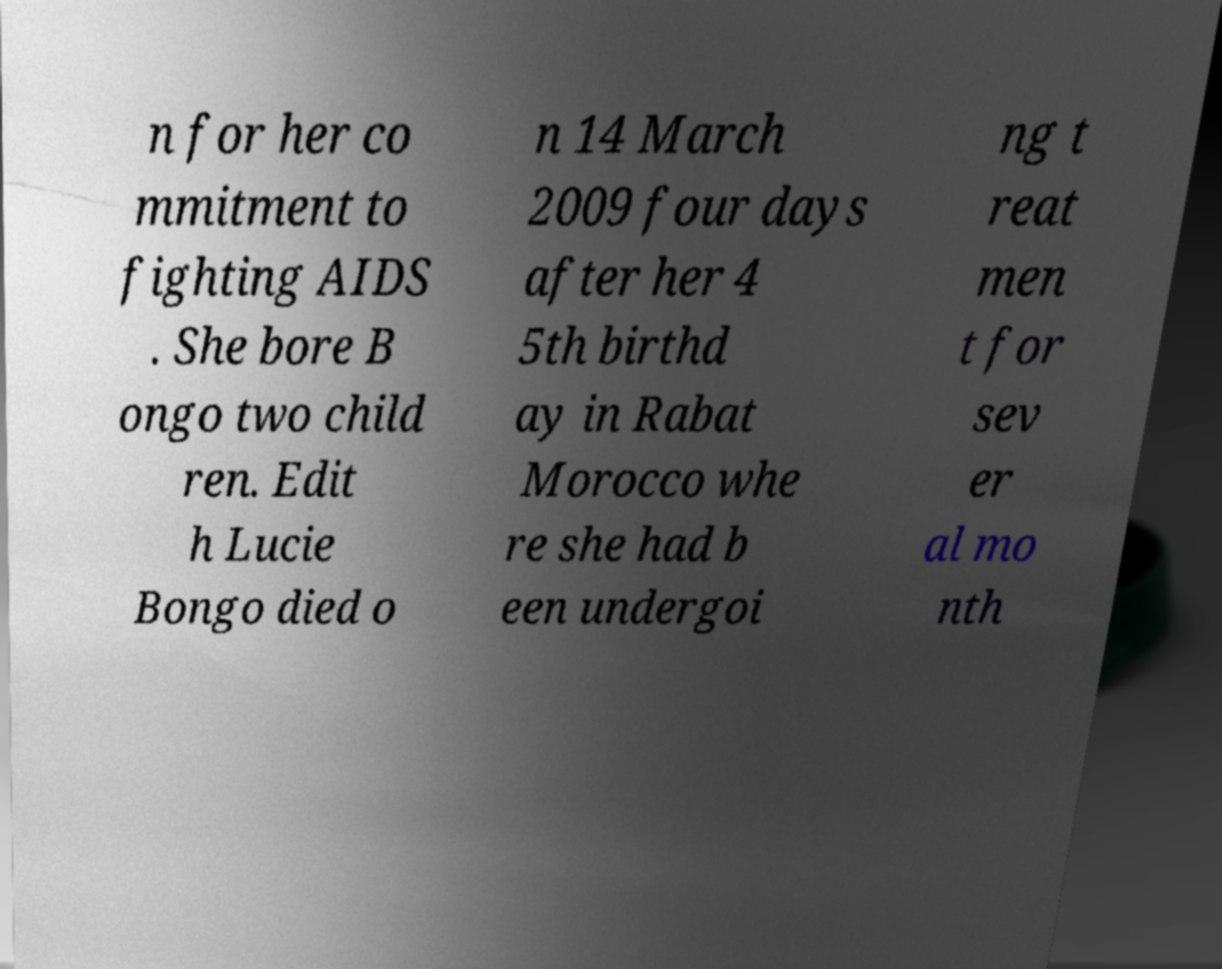Can you accurately transcribe the text from the provided image for me? n for her co mmitment to fighting AIDS . She bore B ongo two child ren. Edit h Lucie Bongo died o n 14 March 2009 four days after her 4 5th birthd ay in Rabat Morocco whe re she had b een undergoi ng t reat men t for sev er al mo nth 